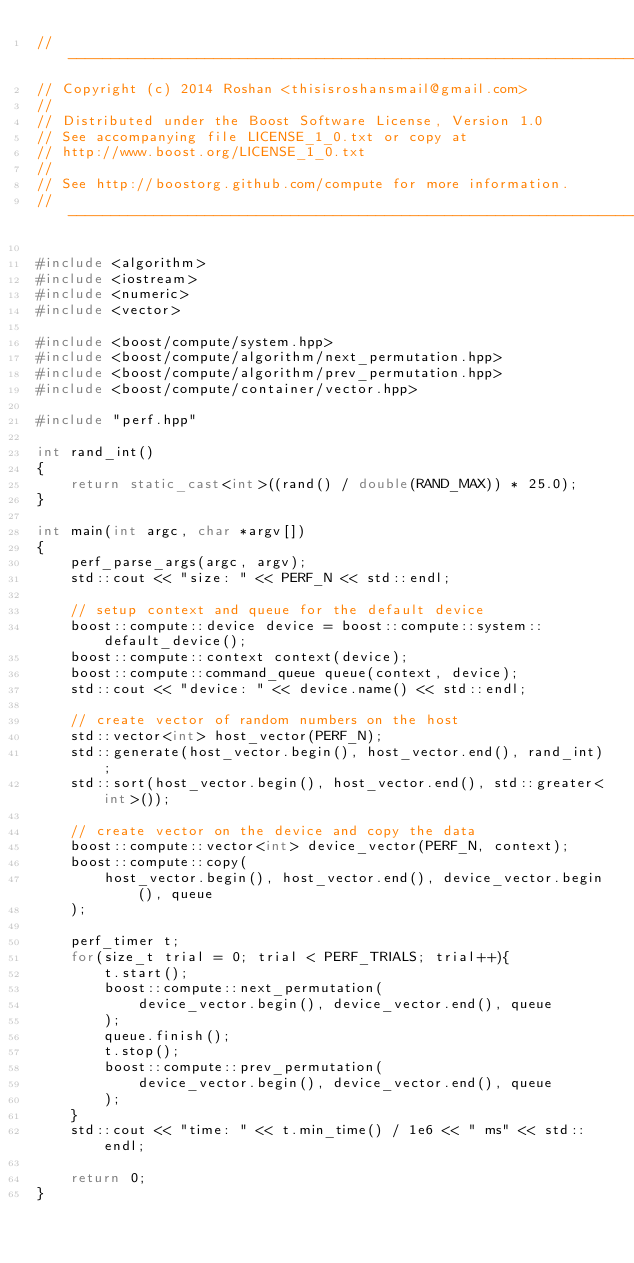<code> <loc_0><loc_0><loc_500><loc_500><_C++_>//---------------------------------------------------------------------------//
// Copyright (c) 2014 Roshan <thisisroshansmail@gmail.com>
//
// Distributed under the Boost Software License, Version 1.0
// See accompanying file LICENSE_1_0.txt or copy at
// http://www.boost.org/LICENSE_1_0.txt
//
// See http://boostorg.github.com/compute for more information.
//---------------------------------------------------------------------------//

#include <algorithm>
#include <iostream>
#include <numeric>
#include <vector>

#include <boost/compute/system.hpp>
#include <boost/compute/algorithm/next_permutation.hpp>
#include <boost/compute/algorithm/prev_permutation.hpp>
#include <boost/compute/container/vector.hpp>

#include "perf.hpp"

int rand_int()
{
    return static_cast<int>((rand() / double(RAND_MAX)) * 25.0);
}

int main(int argc, char *argv[])
{
    perf_parse_args(argc, argv);
    std::cout << "size: " << PERF_N << std::endl;

    // setup context and queue for the default device
    boost::compute::device device = boost::compute::system::default_device();
    boost::compute::context context(device);
    boost::compute::command_queue queue(context, device);
    std::cout << "device: " << device.name() << std::endl;

    // create vector of random numbers on the host
    std::vector<int> host_vector(PERF_N);
    std::generate(host_vector.begin(), host_vector.end(), rand_int);
    std::sort(host_vector.begin(), host_vector.end(), std::greater<int>());

    // create vector on the device and copy the data
    boost::compute::vector<int> device_vector(PERF_N, context);
    boost::compute::copy(
        host_vector.begin(), host_vector.end(), device_vector.begin(), queue
    );

    perf_timer t;
    for(size_t trial = 0; trial < PERF_TRIALS; trial++){
        t.start();
        boost::compute::next_permutation(
            device_vector.begin(), device_vector.end(), queue
        );
        queue.finish();
        t.stop();
        boost::compute::prev_permutation(
            device_vector.begin(), device_vector.end(), queue
        );
    }
    std::cout << "time: " << t.min_time() / 1e6 << " ms" << std::endl;

    return 0;
}
</code> 